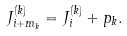Convert formula to latex. <formula><loc_0><loc_0><loc_500><loc_500>J ^ { ( k ) } _ { i + m _ { k } } = J ^ { ( k ) } _ { i } + p _ { k } .</formula> 